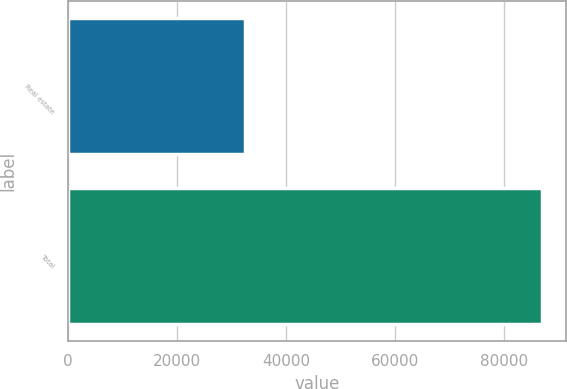Convert chart to OTSL. <chart><loc_0><loc_0><loc_500><loc_500><bar_chart><fcel>Real estate<fcel>Total<nl><fcel>32392<fcel>86935<nl></chart> 